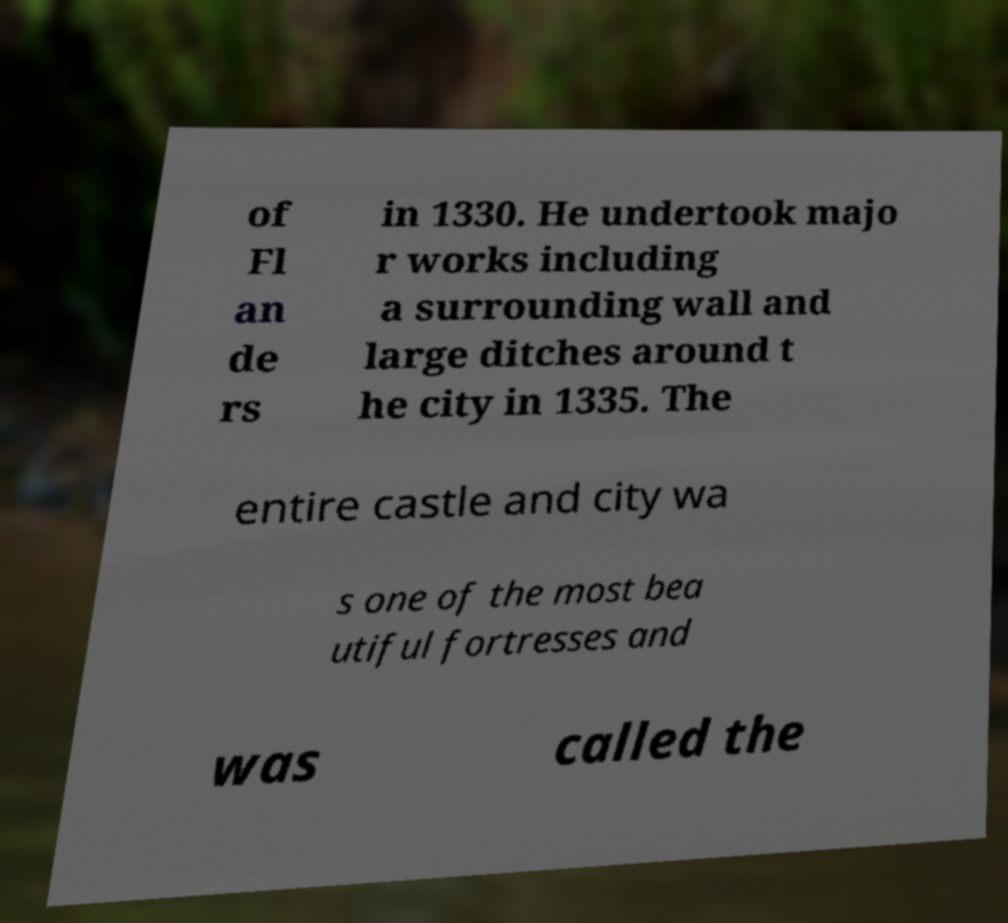Please identify and transcribe the text found in this image. of Fl an de rs in 1330. He undertook majo r works including a surrounding wall and large ditches around t he city in 1335. The entire castle and city wa s one of the most bea utiful fortresses and was called the 